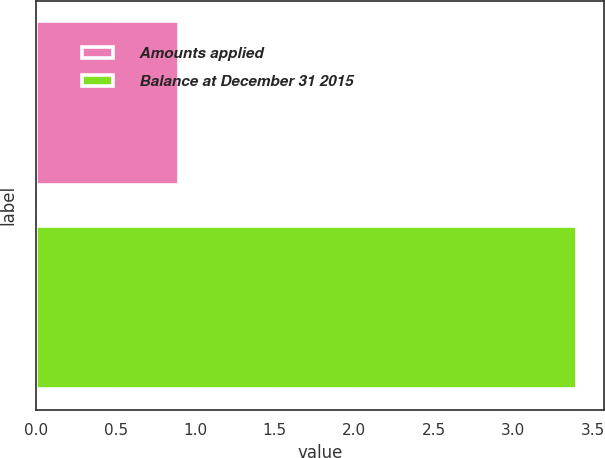<chart> <loc_0><loc_0><loc_500><loc_500><bar_chart><fcel>Amounts applied<fcel>Balance at December 31 2015<nl><fcel>0.9<fcel>3.4<nl></chart> 